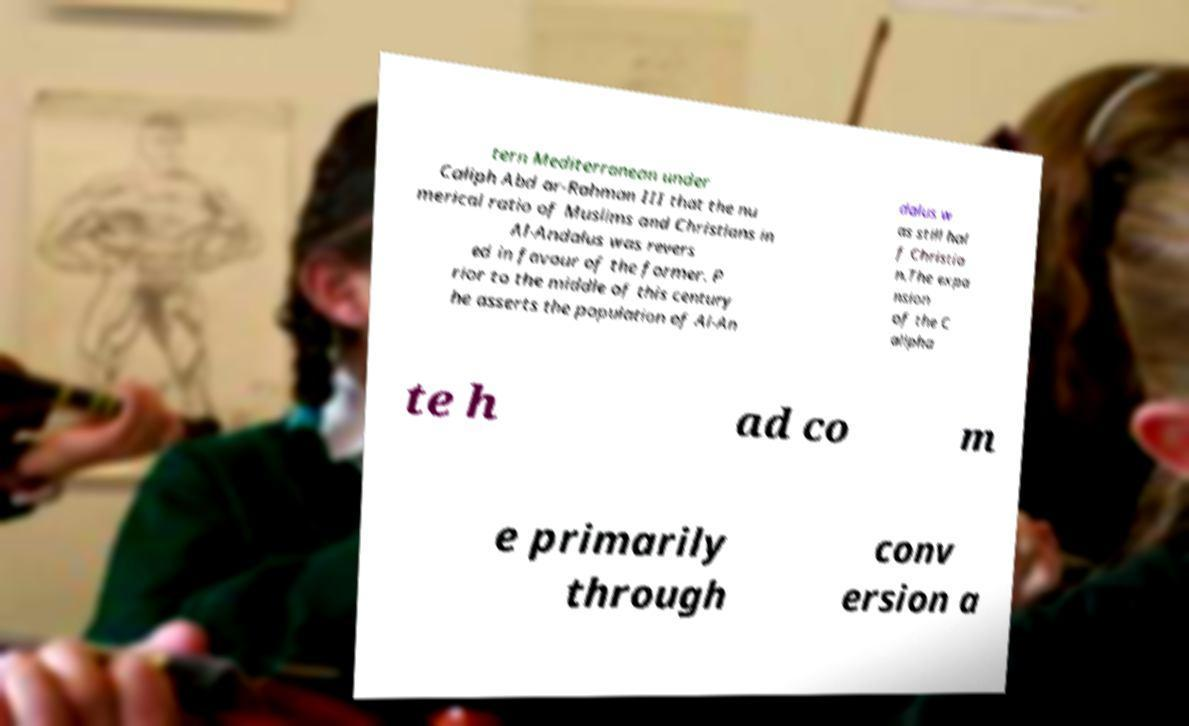Please identify and transcribe the text found in this image. tern Mediterranean under Caliph Abd ar-Rahman III that the nu merical ratio of Muslims and Christians in Al-Andalus was revers ed in favour of the former. P rior to the middle of this century he asserts the population of Al-An dalus w as still hal f Christia n.The expa nsion of the C alipha te h ad co m e primarily through conv ersion a 